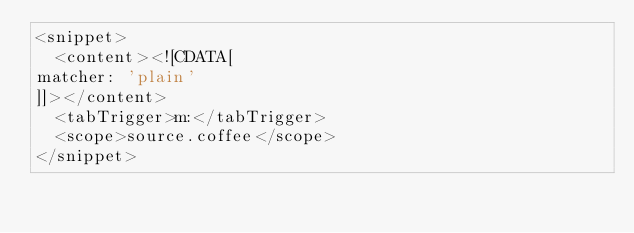<code> <loc_0><loc_0><loc_500><loc_500><_XML_><snippet>
  <content><![CDATA[
matcher: 'plain'
]]></content>
  <tabTrigger>m:</tabTrigger>
  <scope>source.coffee</scope>
</snippet>
</code> 